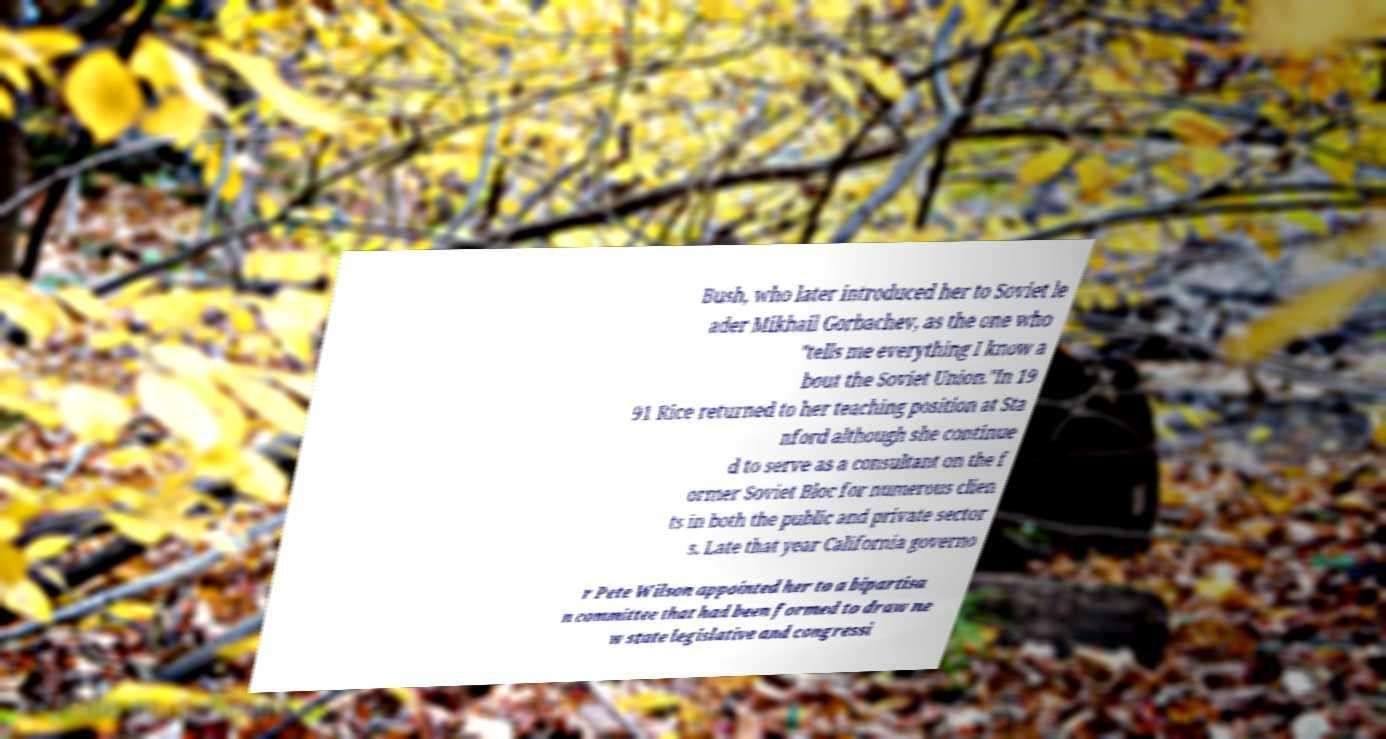There's text embedded in this image that I need extracted. Can you transcribe it verbatim? Bush, who later introduced her to Soviet le ader Mikhail Gorbachev, as the one who "tells me everything I know a bout the Soviet Union."In 19 91 Rice returned to her teaching position at Sta nford although she continue d to serve as a consultant on the f ormer Soviet Bloc for numerous clien ts in both the public and private sector s. Late that year California governo r Pete Wilson appointed her to a bipartisa n committee that had been formed to draw ne w state legislative and congressi 